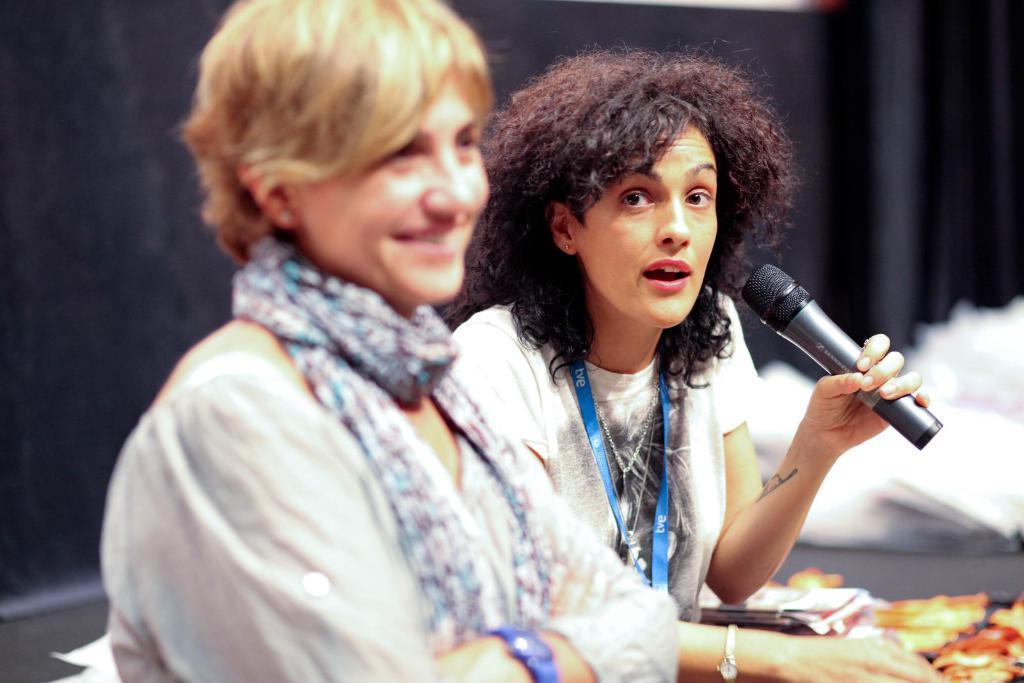Describe this image in one or two sentences. In this image there are two persons, the person with stole around her neck is smiling and the other person with white t-shirt is holding microphone and talking. 